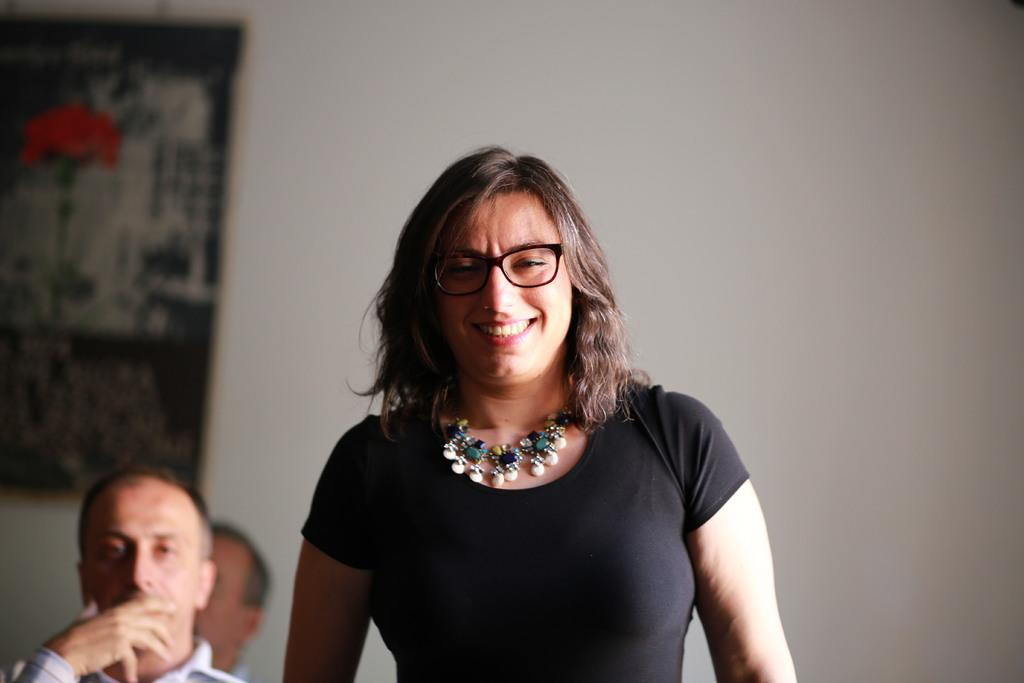What is hanging on the wall in the background of the image? There is a frame on the wall in the background. Who is present in the image? There is a woman in the image. What is the woman wearing on her face? The woman is wearing spectacles. What type of jewelry is the woman wearing? The woman is wearing a necklace. What color is the dress the woman is wearing? The woman is wearing a black dress. What is the woman's facial expression in the image? The woman is smiling. Where are the men located in the image? The men are on the left side of the image. What type of shoes is the woman wearing in the image? There is no mention of shoes in the image, so we cannot determine what type of shoes the woman is wearing. 